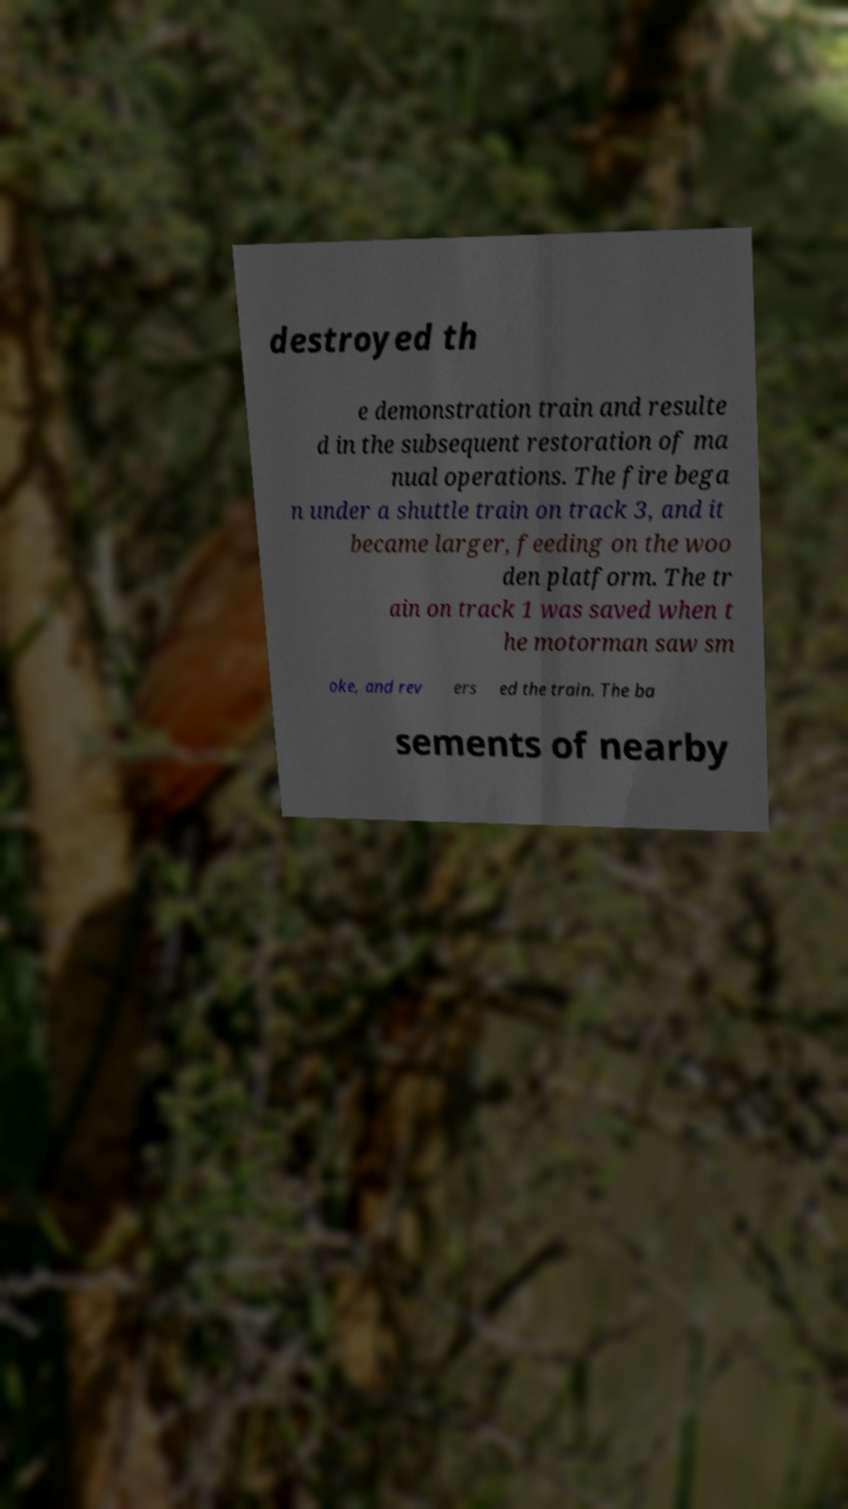Can you read and provide the text displayed in the image?This photo seems to have some interesting text. Can you extract and type it out for me? destroyed th e demonstration train and resulte d in the subsequent restoration of ma nual operations. The fire bega n under a shuttle train on track 3, and it became larger, feeding on the woo den platform. The tr ain on track 1 was saved when t he motorman saw sm oke, and rev ers ed the train. The ba sements of nearby 